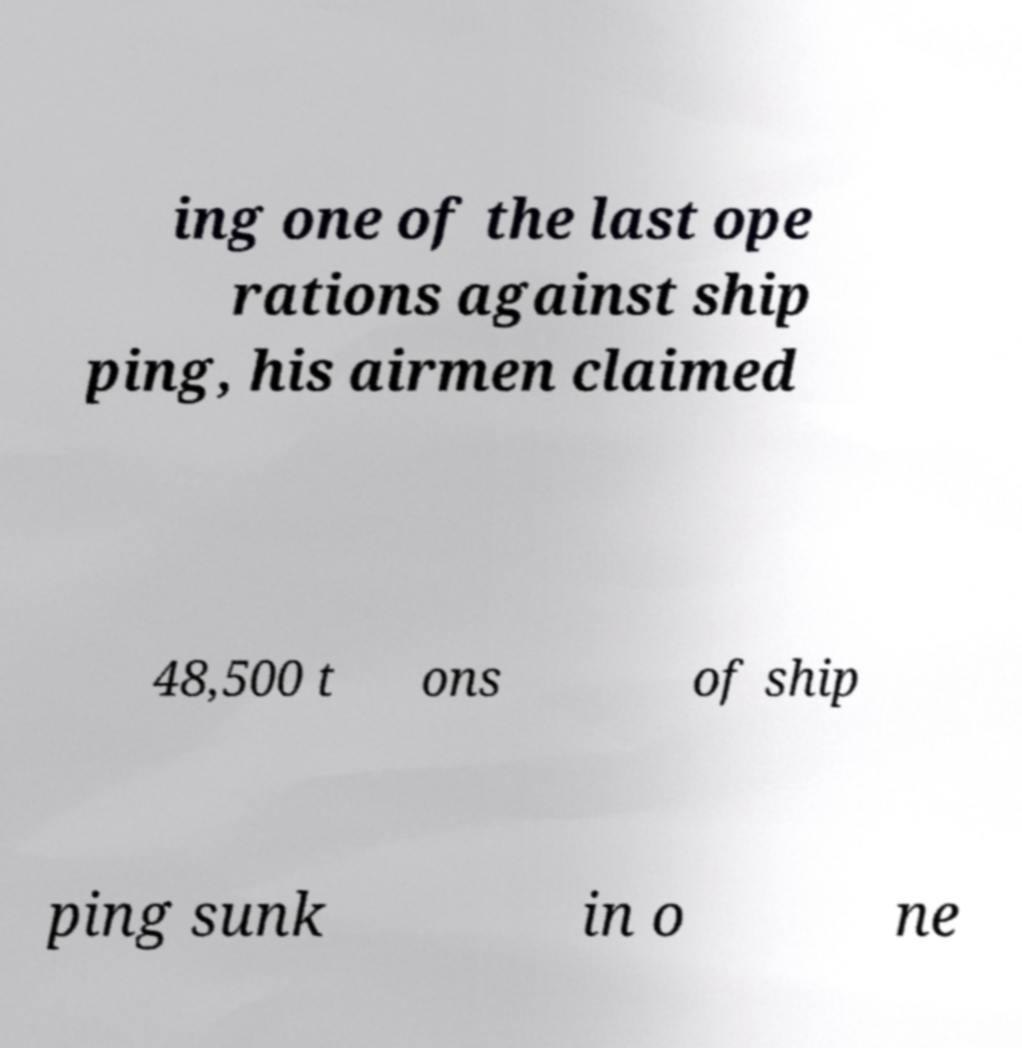Can you read and provide the text displayed in the image?This photo seems to have some interesting text. Can you extract and type it out for me? ing one of the last ope rations against ship ping, his airmen claimed 48,500 t ons of ship ping sunk in o ne 